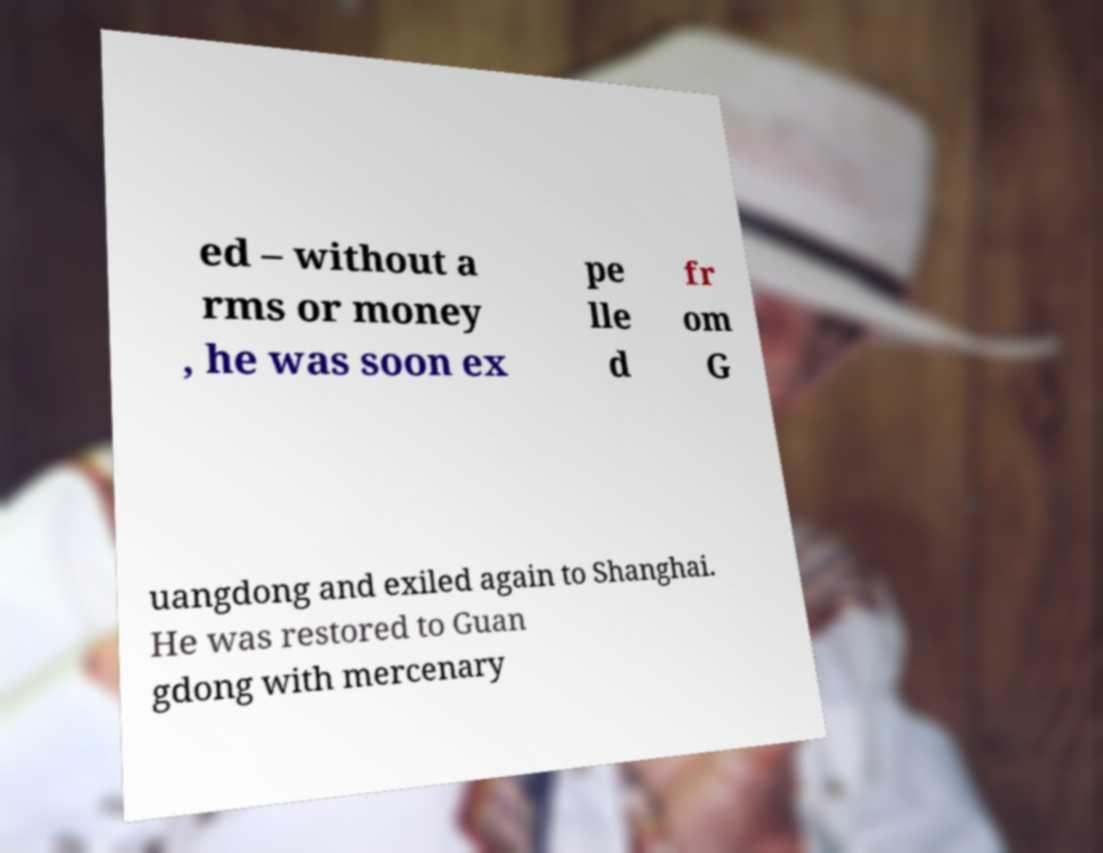Could you extract and type out the text from this image? ed – without a rms or money , he was soon ex pe lle d fr om G uangdong and exiled again to Shanghai. He was restored to Guan gdong with mercenary 